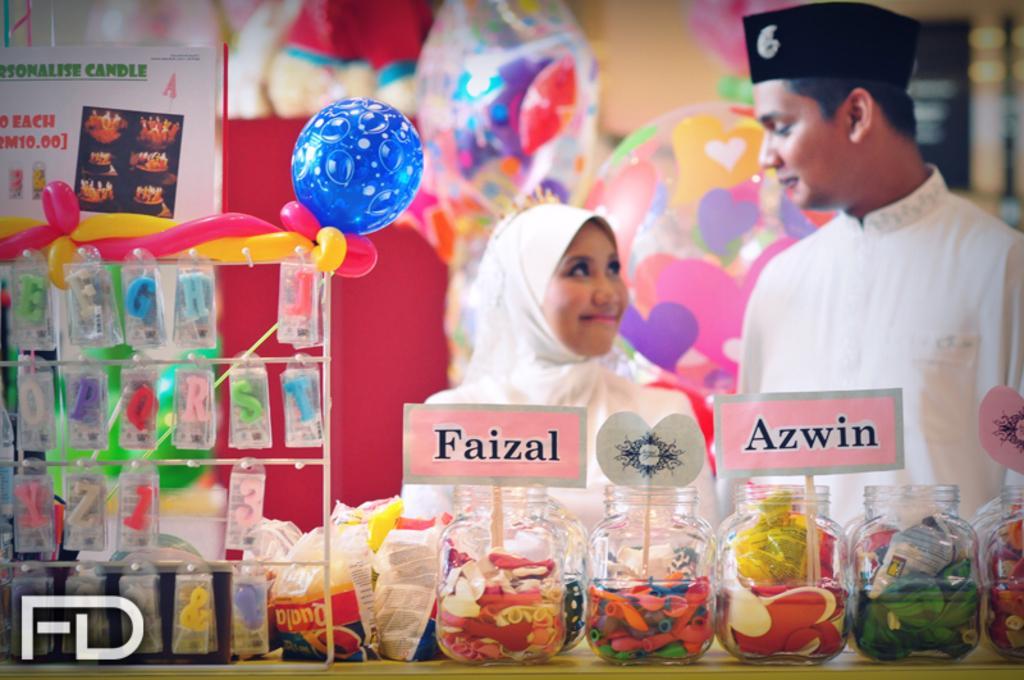Can you describe this image briefly? In this image we can see two persons are standing, and smiling, they are wearing the white dress, in front here are the balloons in the jar, there are name plates, there are alphabets hanging, there it is blurry. 